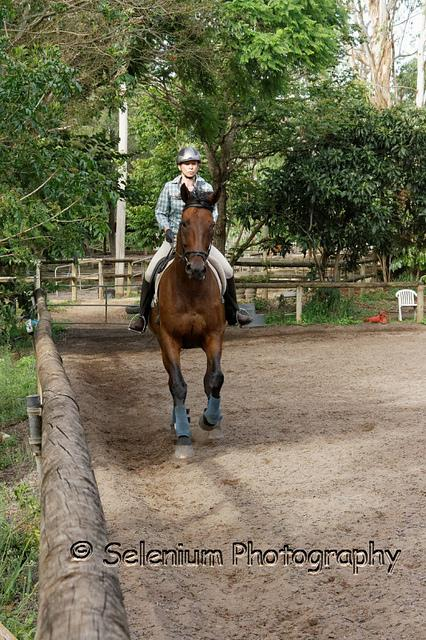In which setting is this person?

Choices:
A) factory
B) farm
C) city
D) beach farm 